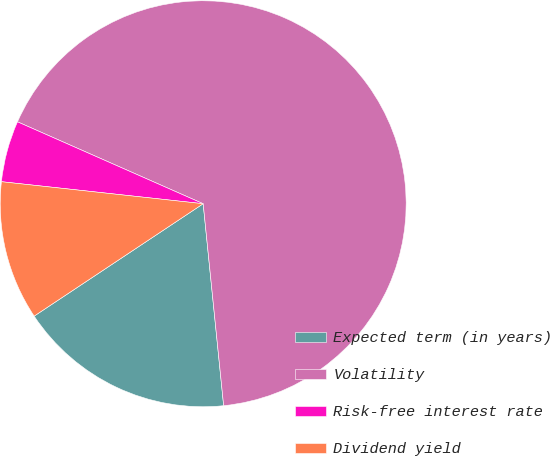<chart> <loc_0><loc_0><loc_500><loc_500><pie_chart><fcel>Expected term (in years)<fcel>Volatility<fcel>Risk-free interest rate<fcel>Dividend yield<nl><fcel>17.27%<fcel>66.78%<fcel>4.88%<fcel>11.07%<nl></chart> 